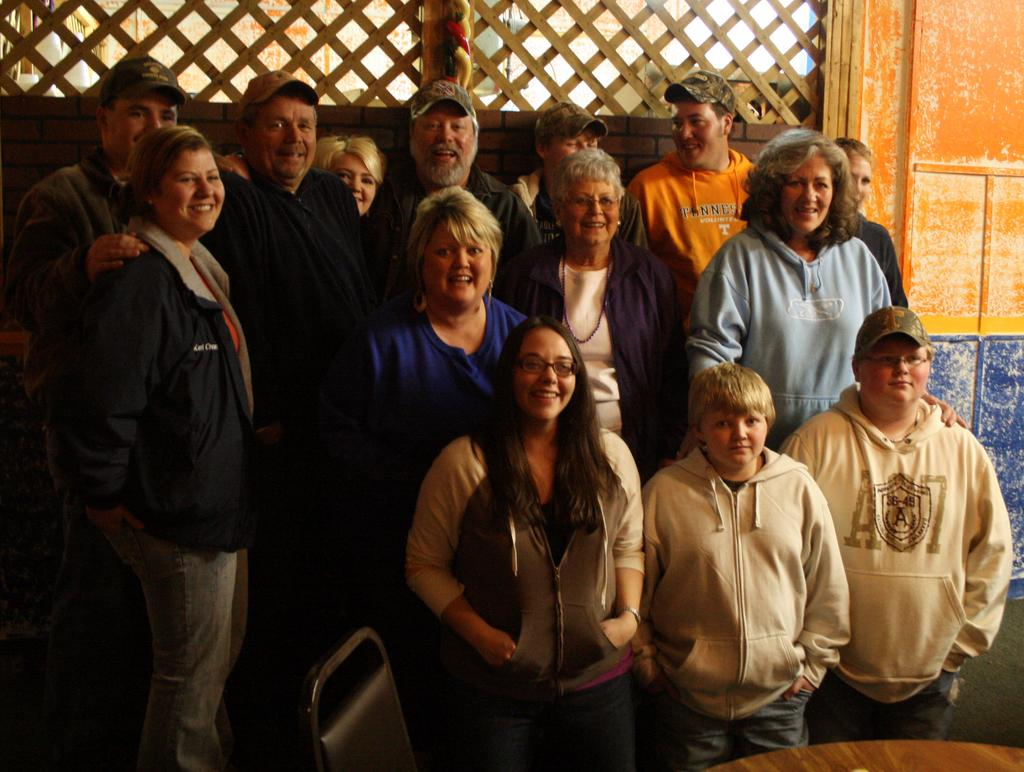How many people are in the group in the image? There is a group of people in the image, but the exact number is not specified. What type of clothing can be seen on some of the people in the group? Some people in the group are wearing hoodies, and some are wearing caps. What is visible in the background of the image? There is a wall in the background of the image. What type of vacation are the people in the image planning? There is no indication in the image that the people are planning a vacation. 